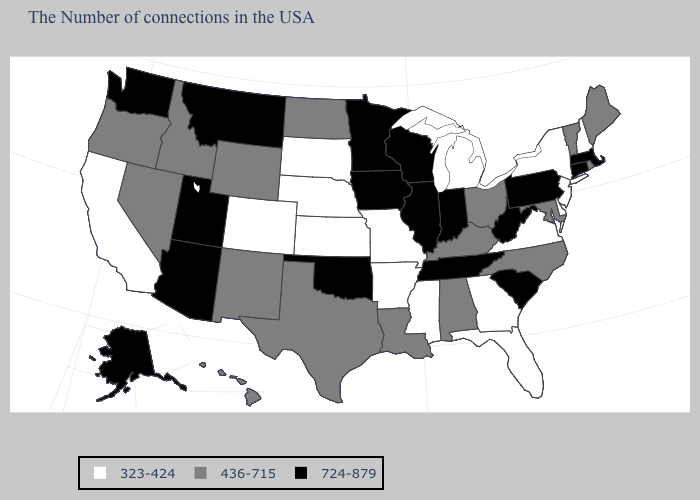What is the value of Colorado?
Quick response, please. 323-424. Name the states that have a value in the range 323-424?
Answer briefly. New Hampshire, New York, New Jersey, Delaware, Virginia, Florida, Georgia, Michigan, Mississippi, Missouri, Arkansas, Kansas, Nebraska, South Dakota, Colorado, California. What is the value of Pennsylvania?
Be succinct. 724-879. Name the states that have a value in the range 724-879?
Write a very short answer. Massachusetts, Connecticut, Pennsylvania, South Carolina, West Virginia, Indiana, Tennessee, Wisconsin, Illinois, Minnesota, Iowa, Oklahoma, Utah, Montana, Arizona, Washington, Alaska. Does Montana have the highest value in the West?
Short answer required. Yes. Which states hav the highest value in the MidWest?
Write a very short answer. Indiana, Wisconsin, Illinois, Minnesota, Iowa. What is the value of Colorado?
Short answer required. 323-424. What is the value of Oklahoma?
Concise answer only. 724-879. Name the states that have a value in the range 724-879?
Quick response, please. Massachusetts, Connecticut, Pennsylvania, South Carolina, West Virginia, Indiana, Tennessee, Wisconsin, Illinois, Minnesota, Iowa, Oklahoma, Utah, Montana, Arizona, Washington, Alaska. Name the states that have a value in the range 724-879?
Give a very brief answer. Massachusetts, Connecticut, Pennsylvania, South Carolina, West Virginia, Indiana, Tennessee, Wisconsin, Illinois, Minnesota, Iowa, Oklahoma, Utah, Montana, Arizona, Washington, Alaska. How many symbols are there in the legend?
Concise answer only. 3. What is the highest value in the MidWest ?
Be succinct. 724-879. Among the states that border North Carolina , does Tennessee have the lowest value?
Short answer required. No. Among the states that border Utah , does Arizona have the highest value?
Short answer required. Yes. What is the highest value in the MidWest ?
Concise answer only. 724-879. 